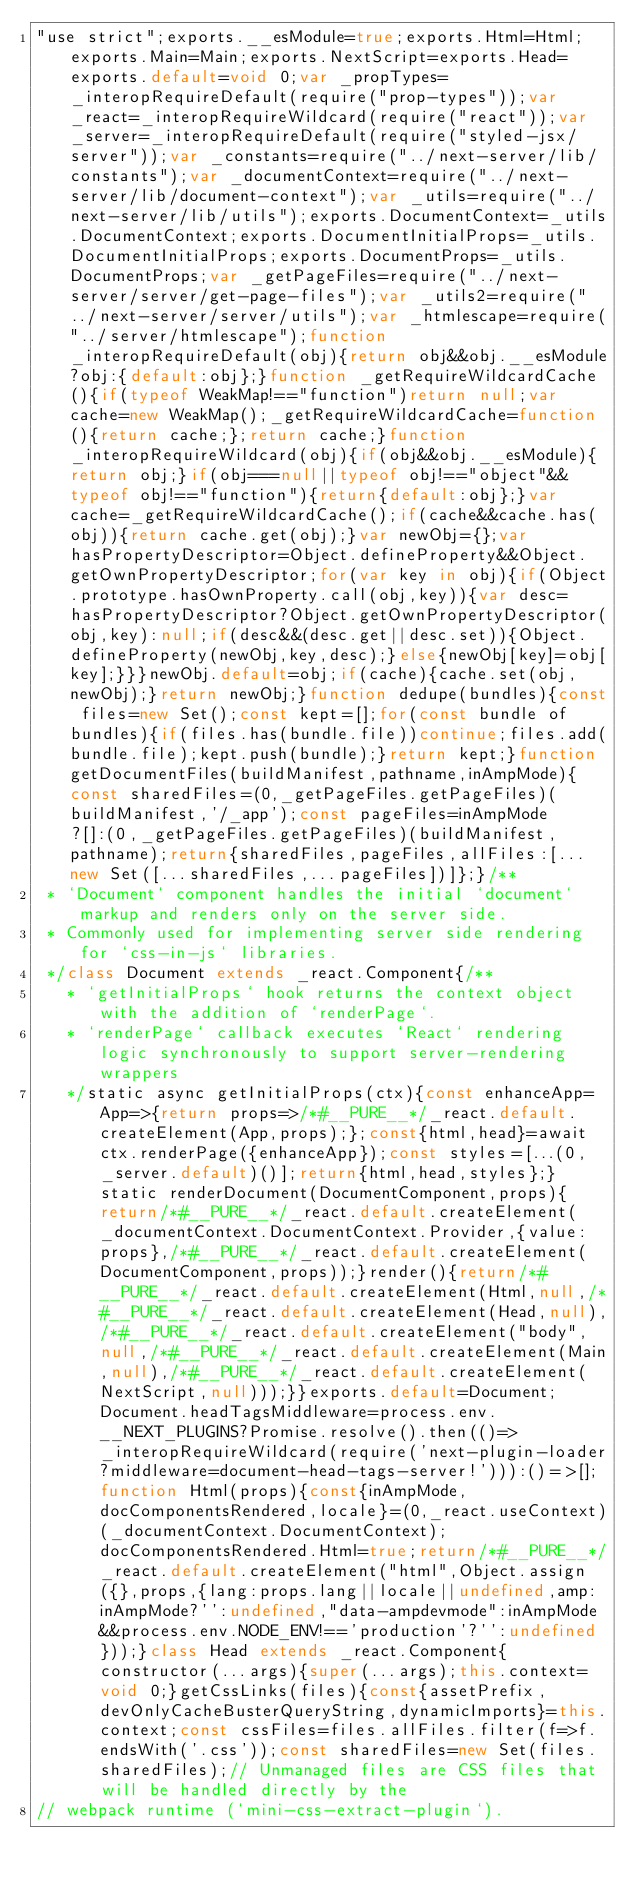<code> <loc_0><loc_0><loc_500><loc_500><_JavaScript_>"use strict";exports.__esModule=true;exports.Html=Html;exports.Main=Main;exports.NextScript=exports.Head=exports.default=void 0;var _propTypes=_interopRequireDefault(require("prop-types"));var _react=_interopRequireWildcard(require("react"));var _server=_interopRequireDefault(require("styled-jsx/server"));var _constants=require("../next-server/lib/constants");var _documentContext=require("../next-server/lib/document-context");var _utils=require("../next-server/lib/utils");exports.DocumentContext=_utils.DocumentContext;exports.DocumentInitialProps=_utils.DocumentInitialProps;exports.DocumentProps=_utils.DocumentProps;var _getPageFiles=require("../next-server/server/get-page-files");var _utils2=require("../next-server/server/utils");var _htmlescape=require("../server/htmlescape");function _interopRequireDefault(obj){return obj&&obj.__esModule?obj:{default:obj};}function _getRequireWildcardCache(){if(typeof WeakMap!=="function")return null;var cache=new WeakMap();_getRequireWildcardCache=function(){return cache;};return cache;}function _interopRequireWildcard(obj){if(obj&&obj.__esModule){return obj;}if(obj===null||typeof obj!=="object"&&typeof obj!=="function"){return{default:obj};}var cache=_getRequireWildcardCache();if(cache&&cache.has(obj)){return cache.get(obj);}var newObj={};var hasPropertyDescriptor=Object.defineProperty&&Object.getOwnPropertyDescriptor;for(var key in obj){if(Object.prototype.hasOwnProperty.call(obj,key)){var desc=hasPropertyDescriptor?Object.getOwnPropertyDescriptor(obj,key):null;if(desc&&(desc.get||desc.set)){Object.defineProperty(newObj,key,desc);}else{newObj[key]=obj[key];}}}newObj.default=obj;if(cache){cache.set(obj,newObj);}return newObj;}function dedupe(bundles){const files=new Set();const kept=[];for(const bundle of bundles){if(files.has(bundle.file))continue;files.add(bundle.file);kept.push(bundle);}return kept;}function getDocumentFiles(buildManifest,pathname,inAmpMode){const sharedFiles=(0,_getPageFiles.getPageFiles)(buildManifest,'/_app');const pageFiles=inAmpMode?[]:(0,_getPageFiles.getPageFiles)(buildManifest,pathname);return{sharedFiles,pageFiles,allFiles:[...new Set([...sharedFiles,...pageFiles])]};}/**
 * `Document` component handles the initial `document` markup and renders only on the server side.
 * Commonly used for implementing server side rendering for `css-in-js` libraries.
 */class Document extends _react.Component{/**
   * `getInitialProps` hook returns the context object with the addition of `renderPage`.
   * `renderPage` callback executes `React` rendering logic synchronously to support server-rendering wrappers
   */static async getInitialProps(ctx){const enhanceApp=App=>{return props=>/*#__PURE__*/_react.default.createElement(App,props);};const{html,head}=await ctx.renderPage({enhanceApp});const styles=[...(0,_server.default)()];return{html,head,styles};}static renderDocument(DocumentComponent,props){return/*#__PURE__*/_react.default.createElement(_documentContext.DocumentContext.Provider,{value:props},/*#__PURE__*/_react.default.createElement(DocumentComponent,props));}render(){return/*#__PURE__*/_react.default.createElement(Html,null,/*#__PURE__*/_react.default.createElement(Head,null),/*#__PURE__*/_react.default.createElement("body",null,/*#__PURE__*/_react.default.createElement(Main,null),/*#__PURE__*/_react.default.createElement(NextScript,null)));}}exports.default=Document;Document.headTagsMiddleware=process.env.__NEXT_PLUGINS?Promise.resolve().then(()=>_interopRequireWildcard(require('next-plugin-loader?middleware=document-head-tags-server!'))):()=>[];function Html(props){const{inAmpMode,docComponentsRendered,locale}=(0,_react.useContext)(_documentContext.DocumentContext);docComponentsRendered.Html=true;return/*#__PURE__*/_react.default.createElement("html",Object.assign({},props,{lang:props.lang||locale||undefined,amp:inAmpMode?'':undefined,"data-ampdevmode":inAmpMode&&process.env.NODE_ENV!=='production'?'':undefined}));}class Head extends _react.Component{constructor(...args){super(...args);this.context=void 0;}getCssLinks(files){const{assetPrefix,devOnlyCacheBusterQueryString,dynamicImports}=this.context;const cssFiles=files.allFiles.filter(f=>f.endsWith('.css'));const sharedFiles=new Set(files.sharedFiles);// Unmanaged files are CSS files that will be handled directly by the
// webpack runtime (`mini-css-extract-plugin`).</code> 